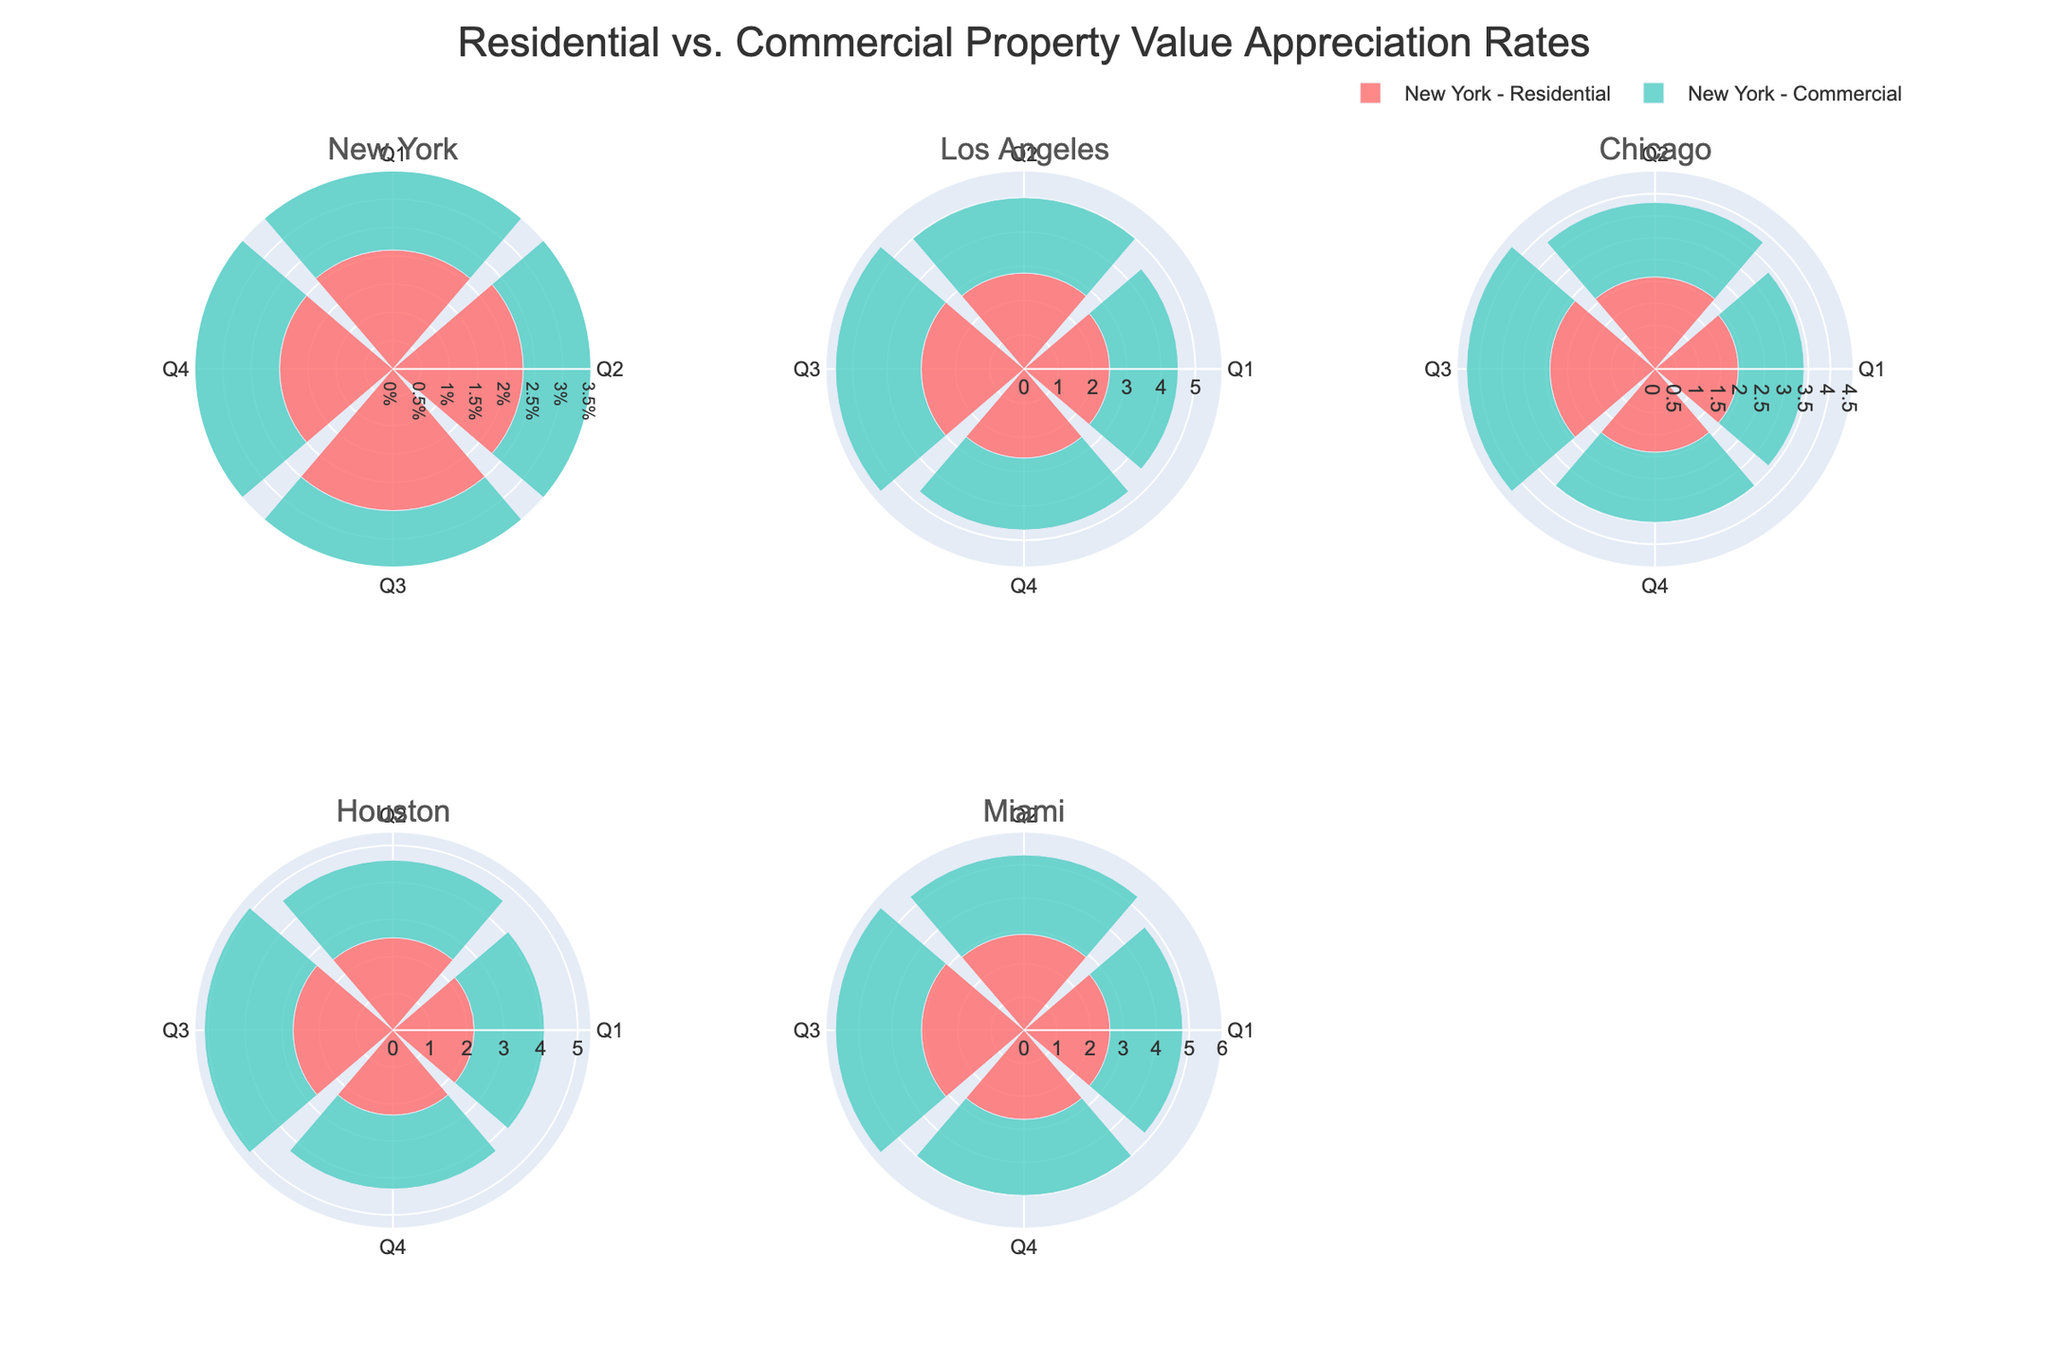What is the title of the figure? The title is usually displayed at the top of the figure. In this case, it should be related to property value appreciation rates.
Answer: Residential vs. Commercial Property Value Appreciation Rates Which city shows the highest appreciation rate for commercial properties in Q3? To find this, look at the commercial properties in each subplot and compare the bars for Q3. Miami's commercial property has the highest appreciation rate in Q3, with a value of 2.6%.
Answer: Miami How do New York's residential and commercial appreciation rates in Q2 compare? For New York, compare the Q2 appreciation rates shown for residential and commercial properties. Residential in Q2 is 2.3%, and commercial in Q2 is 2.0%.
Answer: Residential is higher by 0.3% Which city has the least difference between residential and commercial appreciation rates in Q4? Calculate the differences between residential and commercial rates for Q4 in each city and identify the city with the smallest difference. New York has a difference of 0.1% (2.0% - 1.9%).
Answer: New York Which property type, residential or commercial, generally shows higher appreciation rates across different quarters? Observe the height of the bars for each property type across all subplots and quarters. Residential properties generally have higher appreciation rates.
Answer: Residential What's the average Q3 appreciation rate for residential properties across all cities? Sum the Q3 values for residential properties in all cities and divide by the number of cities. (2.5 + 3.0 + 2.4 + 2.7 + 3.1) / 5 = 2.74%.
Answer: 2.74% Between Q1 and Q4, which quarter generally shows lower appreciation rates for commercial properties across the cities? Compare the bars representing Q1 and Q4 for commercial properties in each subplot. Q1 values are generally lower than Q4.
Answer: Q1 In which city is the difference between Q1 and Q2 appreciation rates for residential properties the largest? Calculate the difference (Q2 - Q1) for residential properties in each city and identify the largest one. Los Angeles has the largest difference, 2.8% - 2.5% = 0.3%.
Answer: Los Angeles Considering Chicago, how much higher is the Q3 appreciation rate for residential properties compared to commercial properties? For Chicago, compare Q3 values of residential (2.4%) and commercial (1.9%), and calculate their difference. 2.4% - 1.9% = 0.5%.
Answer: 0.5% What is the range of appreciation rates shown in the figure? Identify the minimum and maximum appreciation rates across all properties and quarters. The minimum is 1.5% (Chicago Commercial Q1), and the maximum is 3.1% (Miami Residential Q3).
Answer: 1.5% to 3.1% 